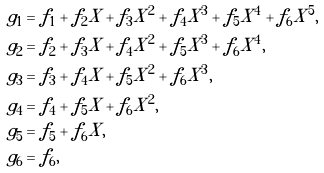Convert formula to latex. <formula><loc_0><loc_0><loc_500><loc_500>g _ { 1 } & = f _ { 1 } + f _ { 2 } X + f _ { 3 } X ^ { 2 } + f _ { 4 } X ^ { 3 } + f _ { 5 } X ^ { 4 } + f _ { 6 } X ^ { 5 } , \\ g _ { 2 } & = f _ { 2 } + f _ { 3 } X + f _ { 4 } X ^ { 2 } + f _ { 5 } X ^ { 3 } + f _ { 6 } X ^ { 4 } , \\ g _ { 3 } & = f _ { 3 } + f _ { 4 } X + f _ { 5 } X ^ { 2 } + f _ { 6 } X ^ { 3 } , \\ g _ { 4 } & = f _ { 4 } + f _ { 5 } X + f _ { 6 } X ^ { 2 } , \\ g _ { 5 } & = f _ { 5 } + f _ { 6 } X , \\ g _ { 6 } & = f _ { 6 } , \\</formula> 